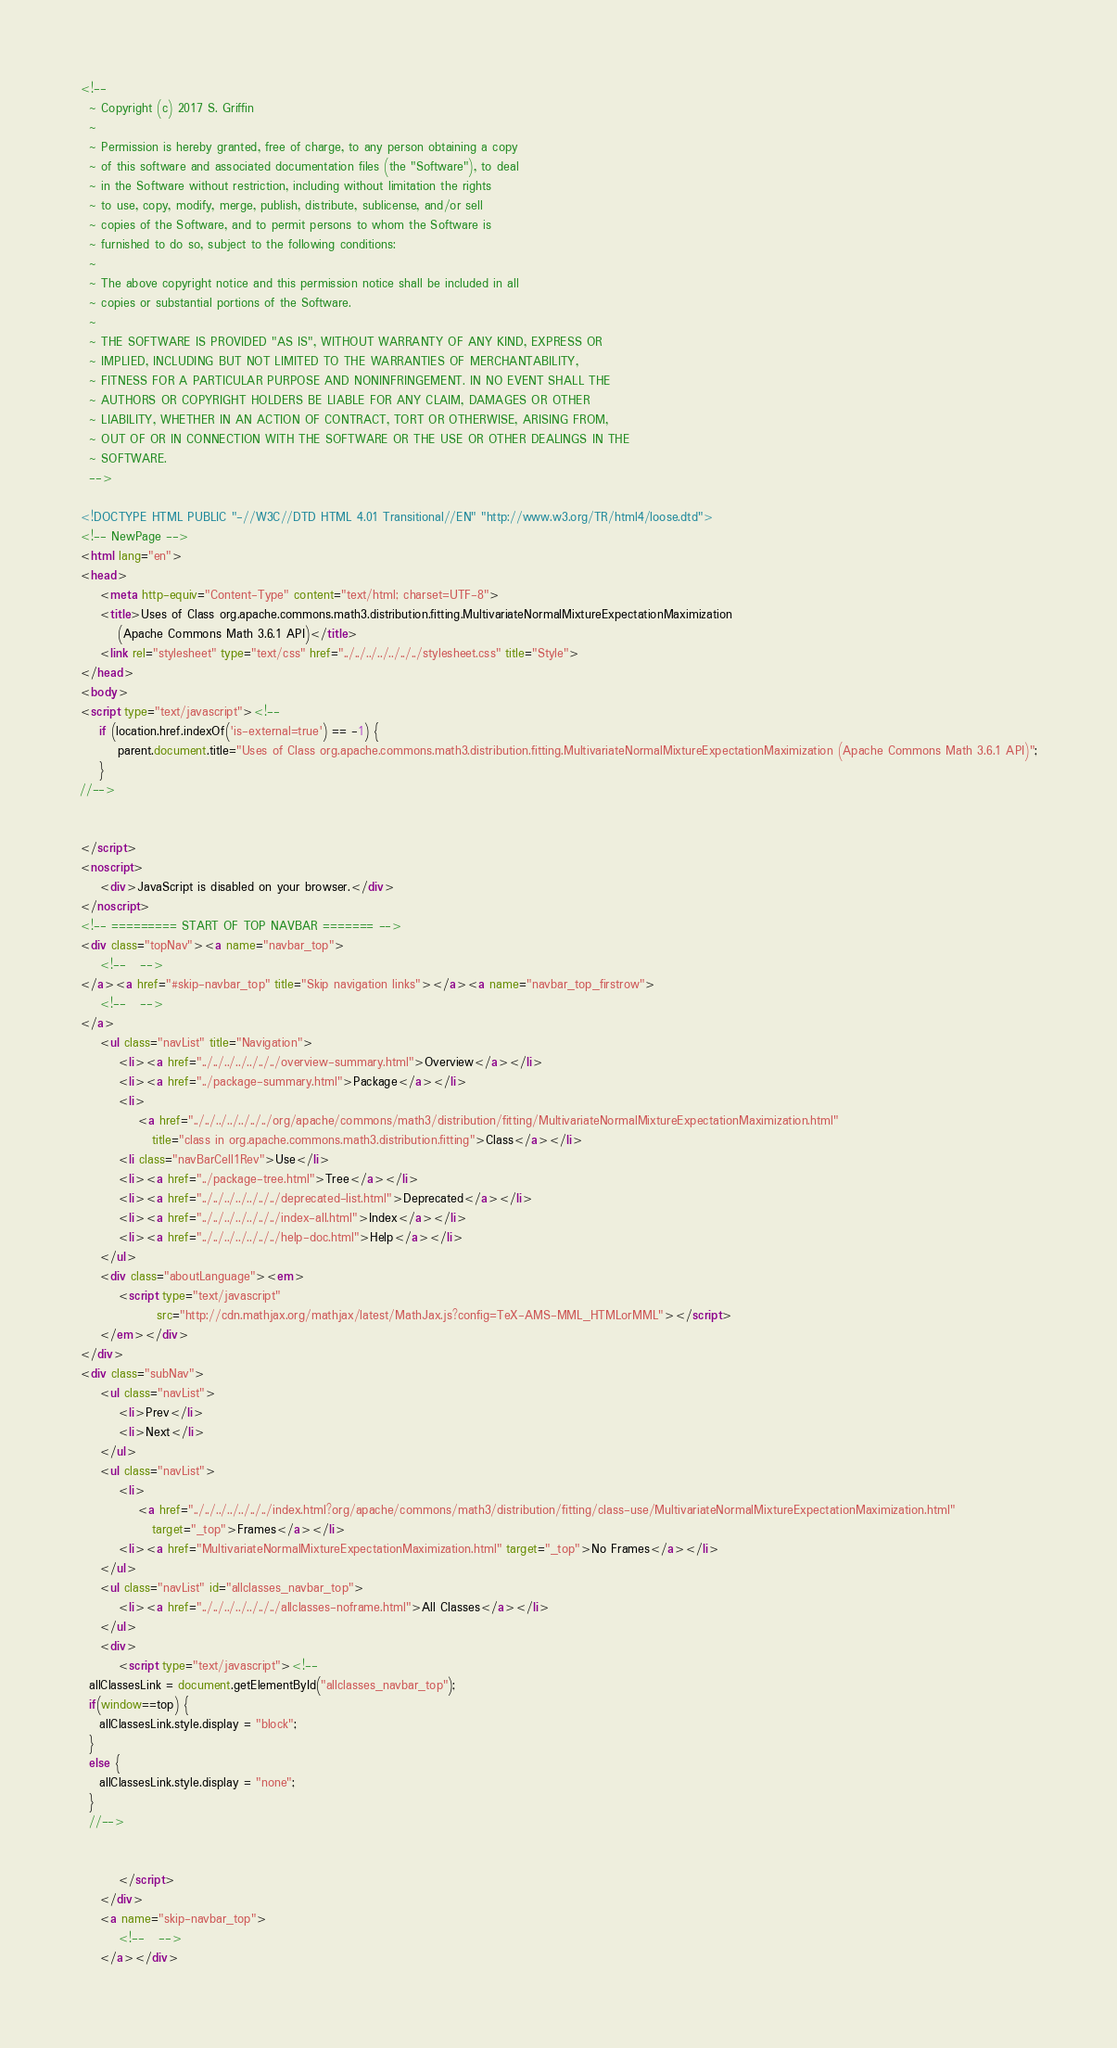Convert code to text. <code><loc_0><loc_0><loc_500><loc_500><_HTML_><!--
  ~ Copyright (c) 2017 S. Griffin
  ~
  ~ Permission is hereby granted, free of charge, to any person obtaining a copy
  ~ of this software and associated documentation files (the "Software"), to deal
  ~ in the Software without restriction, including without limitation the rights
  ~ to use, copy, modify, merge, publish, distribute, sublicense, and/or sell
  ~ copies of the Software, and to permit persons to whom the Software is
  ~ furnished to do so, subject to the following conditions:
  ~
  ~ The above copyright notice and this permission notice shall be included in all
  ~ copies or substantial portions of the Software.
  ~
  ~ THE SOFTWARE IS PROVIDED "AS IS", WITHOUT WARRANTY OF ANY KIND, EXPRESS OR
  ~ IMPLIED, INCLUDING BUT NOT LIMITED TO THE WARRANTIES OF MERCHANTABILITY,
  ~ FITNESS FOR A PARTICULAR PURPOSE AND NONINFRINGEMENT. IN NO EVENT SHALL THE
  ~ AUTHORS OR COPYRIGHT HOLDERS BE LIABLE FOR ANY CLAIM, DAMAGES OR OTHER
  ~ LIABILITY, WHETHER IN AN ACTION OF CONTRACT, TORT OR OTHERWISE, ARISING FROM,
  ~ OUT OF OR IN CONNECTION WITH THE SOFTWARE OR THE USE OR OTHER DEALINGS IN THE
  ~ SOFTWARE.
  -->

<!DOCTYPE HTML PUBLIC "-//W3C//DTD HTML 4.01 Transitional//EN" "http://www.w3.org/TR/html4/loose.dtd">
<!-- NewPage -->
<html lang="en">
<head>
    <meta http-equiv="Content-Type" content="text/html; charset=UTF-8">
    <title>Uses of Class org.apache.commons.math3.distribution.fitting.MultivariateNormalMixtureExpectationMaximization
        (Apache Commons Math 3.6.1 API)</title>
    <link rel="stylesheet" type="text/css" href="../../../../../../../stylesheet.css" title="Style">
</head>
<body>
<script type="text/javascript"><!--
    if (location.href.indexOf('is-external=true') == -1) {
        parent.document.title="Uses of Class org.apache.commons.math3.distribution.fitting.MultivariateNormalMixtureExpectationMaximization (Apache Commons Math 3.6.1 API)";
    }
//-->


</script>
<noscript>
    <div>JavaScript is disabled on your browser.</div>
</noscript>
<!-- ========= START OF TOP NAVBAR ======= -->
<div class="topNav"><a name="navbar_top">
    <!--   -->
</a><a href="#skip-navbar_top" title="Skip navigation links"></a><a name="navbar_top_firstrow">
    <!--   -->
</a>
    <ul class="navList" title="Navigation">
        <li><a href="../../../../../../../overview-summary.html">Overview</a></li>
        <li><a href="../package-summary.html">Package</a></li>
        <li>
            <a href="../../../../../../../org/apache/commons/math3/distribution/fitting/MultivariateNormalMixtureExpectationMaximization.html"
               title="class in org.apache.commons.math3.distribution.fitting">Class</a></li>
        <li class="navBarCell1Rev">Use</li>
        <li><a href="../package-tree.html">Tree</a></li>
        <li><a href="../../../../../../../deprecated-list.html">Deprecated</a></li>
        <li><a href="../../../../../../../index-all.html">Index</a></li>
        <li><a href="../../../../../../../help-doc.html">Help</a></li>
    </ul>
    <div class="aboutLanguage"><em>
        <script type="text/javascript"
                src="http://cdn.mathjax.org/mathjax/latest/MathJax.js?config=TeX-AMS-MML_HTMLorMML"></script>
    </em></div>
</div>
<div class="subNav">
    <ul class="navList">
        <li>Prev</li>
        <li>Next</li>
    </ul>
    <ul class="navList">
        <li>
            <a href="../../../../../../../index.html?org/apache/commons/math3/distribution/fitting/class-use/MultivariateNormalMixtureExpectationMaximization.html"
               target="_top">Frames</a></li>
        <li><a href="MultivariateNormalMixtureExpectationMaximization.html" target="_top">No Frames</a></li>
    </ul>
    <ul class="navList" id="allclasses_navbar_top">
        <li><a href="../../../../../../../allclasses-noframe.html">All Classes</a></li>
    </ul>
    <div>
        <script type="text/javascript"><!--
  allClassesLink = document.getElementById("allclasses_navbar_top");
  if(window==top) {
    allClassesLink.style.display = "block";
  }
  else {
    allClassesLink.style.display = "none";
  }
  //-->


        </script>
    </div>
    <a name="skip-navbar_top">
        <!--   -->
    </a></div></code> 